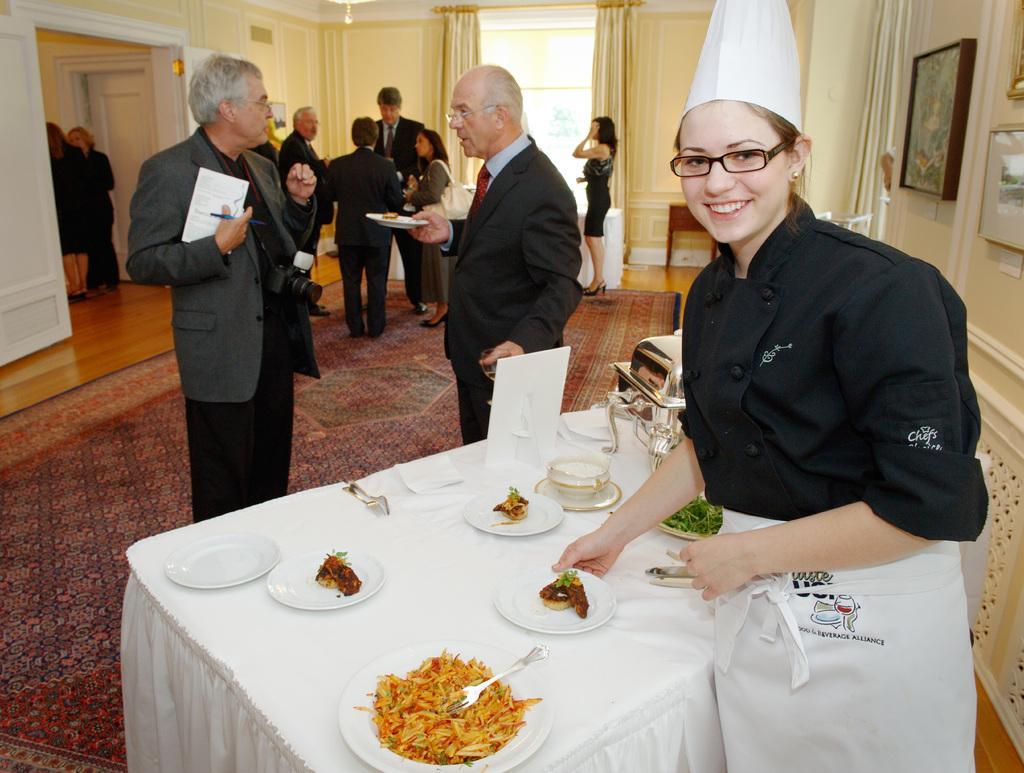Describe this image in one or two sentences. This is a room,here we see a woman smiling and serving food on the table. Next to the table we see two men talking to each other. In the background we see four people in which one is woman. And next to that group at the corner we see a woman standing. 